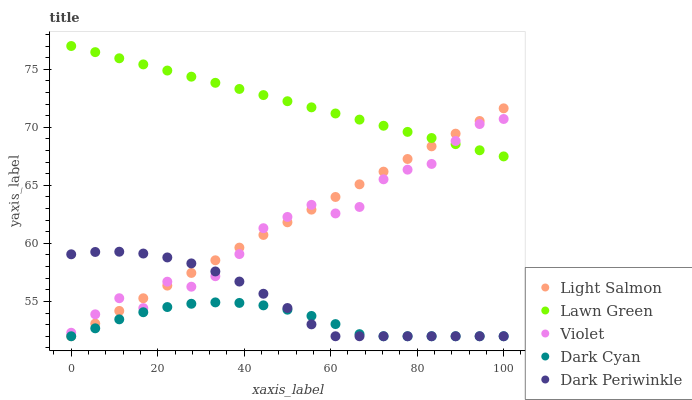Does Dark Cyan have the minimum area under the curve?
Answer yes or no. Yes. Does Lawn Green have the maximum area under the curve?
Answer yes or no. Yes. Does Light Salmon have the minimum area under the curve?
Answer yes or no. No. Does Light Salmon have the maximum area under the curve?
Answer yes or no. No. Is Light Salmon the smoothest?
Answer yes or no. Yes. Is Violet the roughest?
Answer yes or no. Yes. Is Lawn Green the smoothest?
Answer yes or no. No. Is Lawn Green the roughest?
Answer yes or no. No. Does Dark Cyan have the lowest value?
Answer yes or no. Yes. Does Lawn Green have the lowest value?
Answer yes or no. No. Does Lawn Green have the highest value?
Answer yes or no. Yes. Does Light Salmon have the highest value?
Answer yes or no. No. Is Dark Cyan less than Violet?
Answer yes or no. Yes. Is Lawn Green greater than Dark Periwinkle?
Answer yes or no. Yes. Does Light Salmon intersect Dark Cyan?
Answer yes or no. Yes. Is Light Salmon less than Dark Cyan?
Answer yes or no. No. Is Light Salmon greater than Dark Cyan?
Answer yes or no. No. Does Dark Cyan intersect Violet?
Answer yes or no. No. 